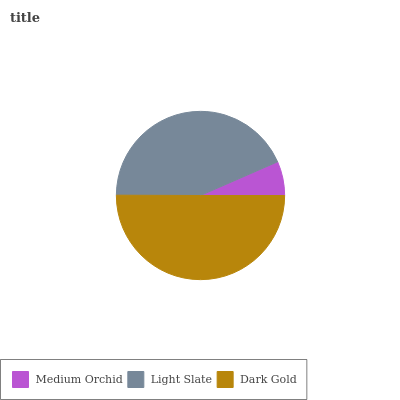Is Medium Orchid the minimum?
Answer yes or no. Yes. Is Dark Gold the maximum?
Answer yes or no. Yes. Is Light Slate the minimum?
Answer yes or no. No. Is Light Slate the maximum?
Answer yes or no. No. Is Light Slate greater than Medium Orchid?
Answer yes or no. Yes. Is Medium Orchid less than Light Slate?
Answer yes or no. Yes. Is Medium Orchid greater than Light Slate?
Answer yes or no. No. Is Light Slate less than Medium Orchid?
Answer yes or no. No. Is Light Slate the high median?
Answer yes or no. Yes. Is Light Slate the low median?
Answer yes or no. Yes. Is Dark Gold the high median?
Answer yes or no. No. Is Medium Orchid the low median?
Answer yes or no. No. 